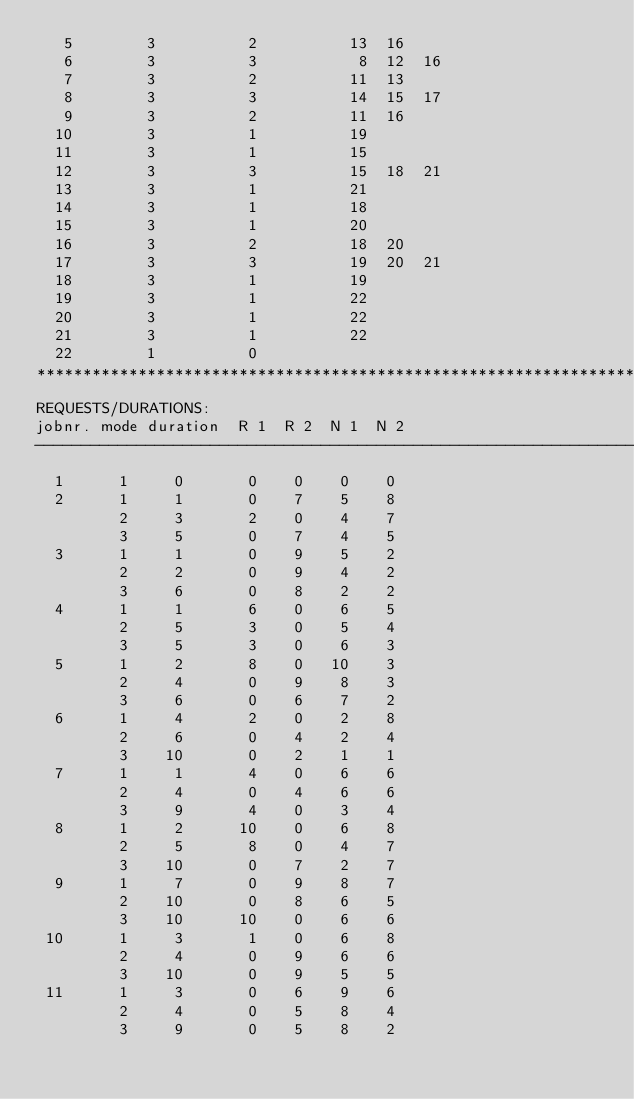<code> <loc_0><loc_0><loc_500><loc_500><_ObjectiveC_>   5        3          2          13  16
   6        3          3           8  12  16
   7        3          2          11  13
   8        3          3          14  15  17
   9        3          2          11  16
  10        3          1          19
  11        3          1          15
  12        3          3          15  18  21
  13        3          1          21
  14        3          1          18
  15        3          1          20
  16        3          2          18  20
  17        3          3          19  20  21
  18        3          1          19
  19        3          1          22
  20        3          1          22
  21        3          1          22
  22        1          0        
************************************************************************
REQUESTS/DURATIONS:
jobnr. mode duration  R 1  R 2  N 1  N 2
------------------------------------------------------------------------
  1      1     0       0    0    0    0
  2      1     1       0    7    5    8
         2     3       2    0    4    7
         3     5       0    7    4    5
  3      1     1       0    9    5    2
         2     2       0    9    4    2
         3     6       0    8    2    2
  4      1     1       6    0    6    5
         2     5       3    0    5    4
         3     5       3    0    6    3
  5      1     2       8    0   10    3
         2     4       0    9    8    3
         3     6       0    6    7    2
  6      1     4       2    0    2    8
         2     6       0    4    2    4
         3    10       0    2    1    1
  7      1     1       4    0    6    6
         2     4       0    4    6    6
         3     9       4    0    3    4
  8      1     2      10    0    6    8
         2     5       8    0    4    7
         3    10       0    7    2    7
  9      1     7       0    9    8    7
         2    10       0    8    6    5
         3    10      10    0    6    6
 10      1     3       1    0    6    8
         2     4       0    9    6    6
         3    10       0    9    5    5
 11      1     3       0    6    9    6
         2     4       0    5    8    4
         3     9       0    5    8    2</code> 